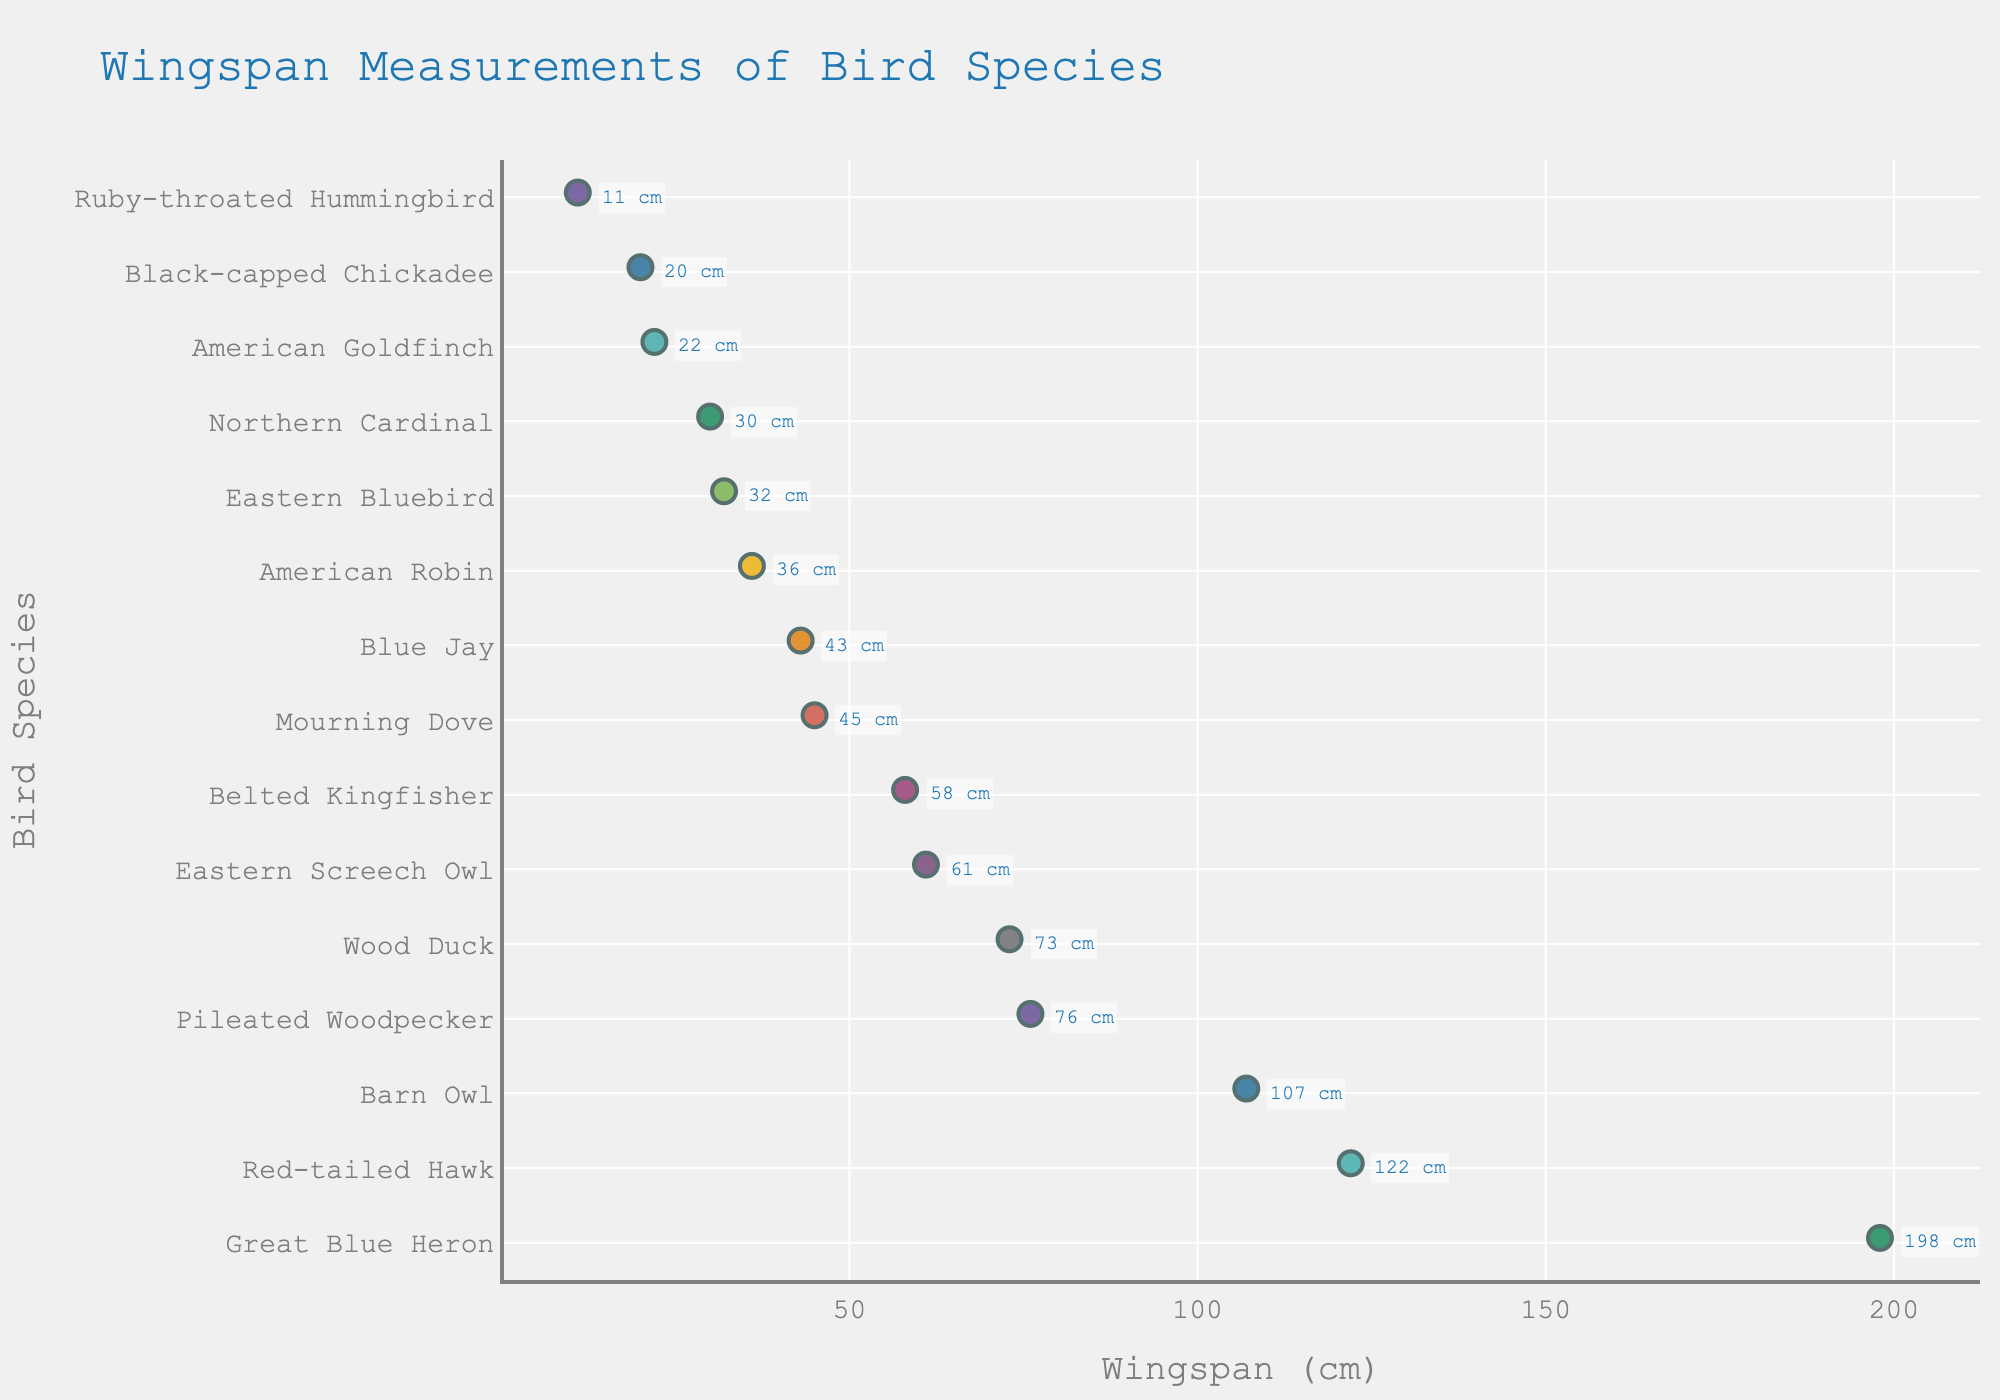What's the title of the figure? The title is prominently displayed at the top of the figure.
Answer: Wingspan Measurements of Bird Species What is the wingspan of the Great Blue Heron? The wingspan of each bird species is labeled next to the point representing that species on the y-axis. The Great Blue Heron is labeled with its corresponding wingspan.
Answer: 198 cm Which bird species has the smallest wingspan? By examining the x-axis, we can see that the Ruby-throated Hummingbird has the smallest wingspan, as its point is located furthest to the left.
Answer: Ruby-throated Hummingbird How many bird species have wingspans greater than 100 cm? By counting the points on the plot that are to the right of the 100 cm mark on the x-axis, we determine the number of species with wingspans above 100 cm.
Answer: 3 What is the average wingspan of the Black-capped Chickadee and the American Goldfinch? We find the wingspans of both birds, add them together, and then divide by 2 to find the average: (20 cm + 22 cm) / 2 = 21 cm.
Answer: 21 cm Which bird species has a wingspan between 70 cm and 80 cm? By locating the range between 70 cm and 80 cm on the x-axis, we see that the Wood Duck and Pileated Woodpecker have wingspans within this range.
Answer: Wood Duck and Pileated Woodpecker Compare the wingspans of the Barn Owl and Eastern Screech Owl. Which one is larger? By locating both birds on the y-axis and comparing their wingspan values on the x-axis, we can see that the Barn Owl's wingspan is larger than the Eastern Screech Owl's.
Answer: Barn Owl What is the median wingspan value among all bird species in the figure? First, sort all wingspan values in ascending order: [11, 20, 22, 30, 32, 36, 43, 45, 58, 61, 73, 76, 107, 122, 198]. Since there are 15 values, the median is the 8th value.
Answer: 45 cm Which bird species are represented by the two rightmost points on the figure? The two rightmost points can be identified by looking at the labels beside these points on the x-axis. They are the Great Blue Heron (198 cm) and the Red-tailed Hawk (122 cm).
Answer: Great Blue Heron and Red-tailed Hawk 